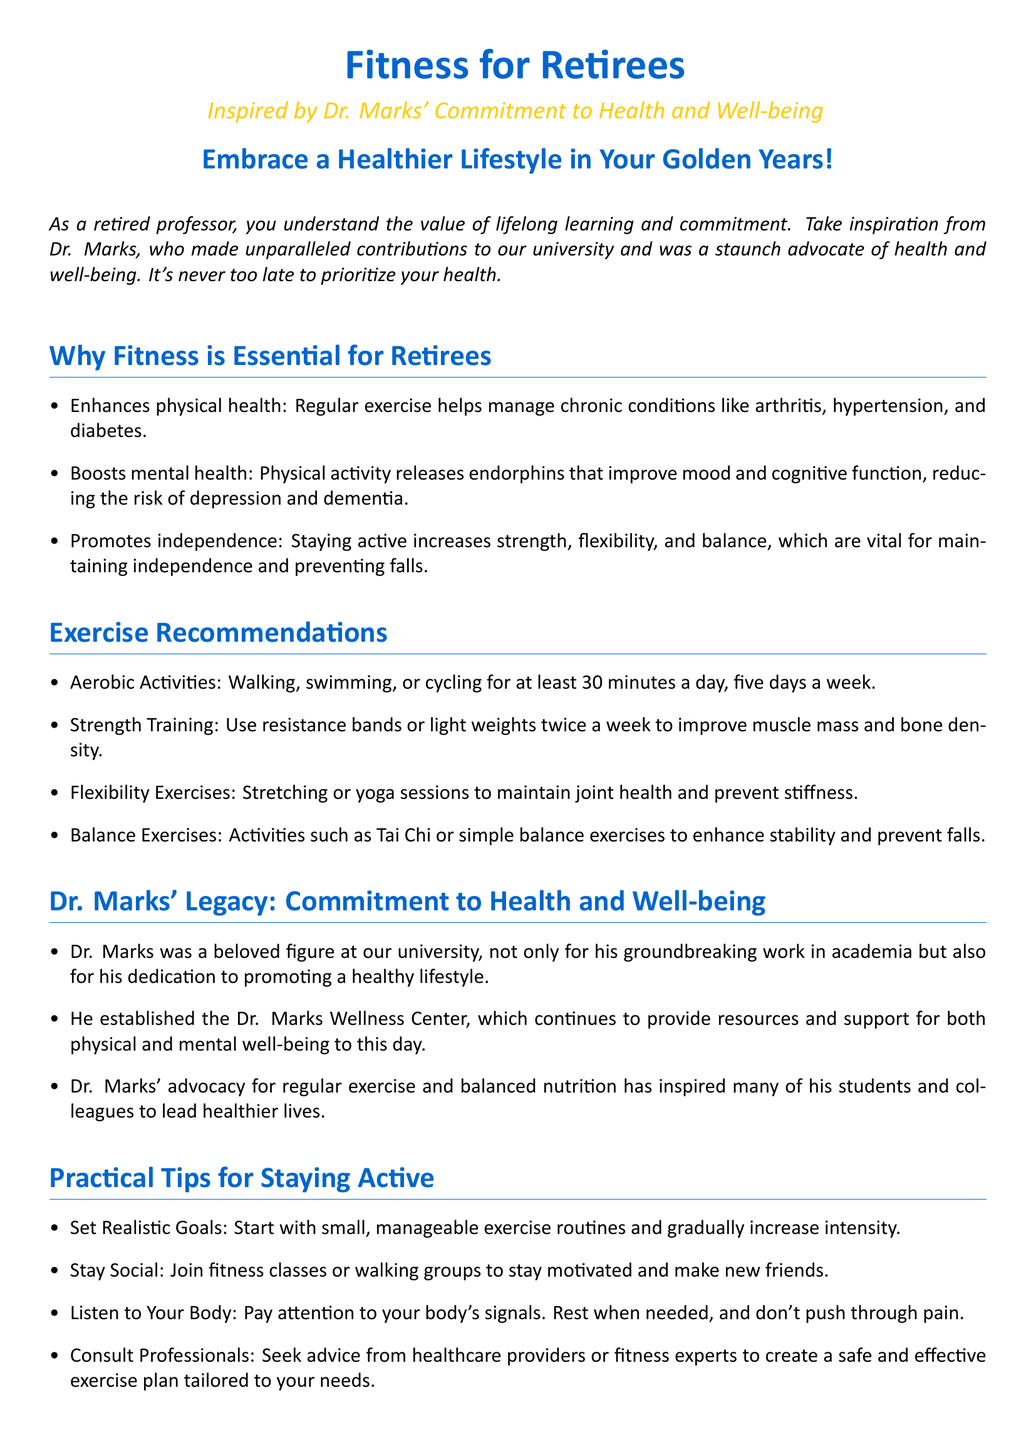What is the document's main title? The main title indicates the focus of the flyer and is prominently displayed at the top of the document.
Answer: Fitness for Retirees Who inspired the fitness initiative? This information reflects the individual who significantly contributed to health and well-being within the document.
Answer: Dr. Marks What type of exercise is recommended for at least 30 minutes a day? This involves specifying which aerobic activity is highlighted within the exercise recommendations.
Answer: Walking How many times a week should strength training be performed? The recommendation for frequency of strength training reveals the optimal plan outlined in the document.
Answer: Twice a week What is one legacy of Dr. Marks mentioned in the document? This reflects on Dr. Marks' contributions beyond academia and highlights importance in health promotion.
Answer: Dr. Marks Wellness Center What type of program is suggested to maintain social interaction while exercising? This question focuses on enhancing motivation through community engagement as discussed in the flyer.
Answer: Fitness classes What flexible exercise is recommended for joint health? The question centers on specific types of activities that promote flexibility mentioned in the recommendations.
Answer: Yoga sessions What is one online resource mentioned for seniors? This focuses on an example of a digital platform that offers fitness information useful for retirees.
Answer: SilverSneakers.com Why is exercise important for retirees regarding mood? This question leads to understanding the mental health benefits explained in the document.
Answer: Releases endorphins 